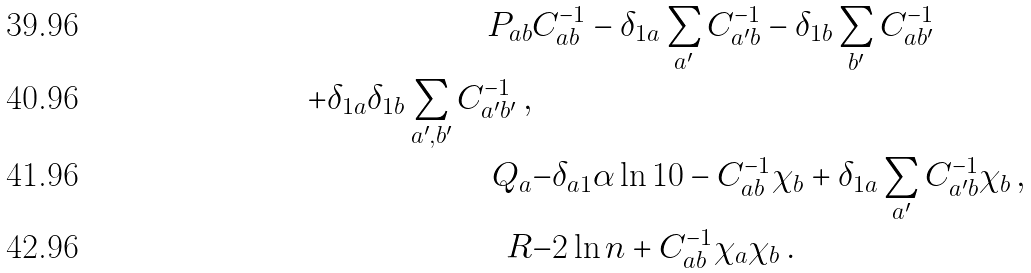Convert formula to latex. <formula><loc_0><loc_0><loc_500><loc_500>P _ { a b } & C ^ { - 1 } _ { a b } - \delta _ { 1 a } \sum _ { a ^ { \prime } } C ^ { - 1 } _ { a ^ { \prime } b } - \delta _ { 1 b } \sum _ { b ^ { \prime } } C ^ { - 1 } _ { a b ^ { \prime } } \\ + \delta _ { 1 a } \delta _ { 1 b } \sum _ { a ^ { \prime } , b ^ { \prime } } C ^ { - 1 } _ { a ^ { \prime } b ^ { \prime } } \, , \\ Q _ { a } & { - \delta _ { a 1 } } \alpha \ln 1 0 - C ^ { - 1 } _ { a b } \chi _ { b } + \delta _ { 1 a } \sum _ { a ^ { \prime } } C ^ { - 1 } _ { a ^ { \prime } b } \chi _ { b } \, , \\ R & { - 2 \ln n } + C ^ { - 1 } _ { a b } \chi _ { a } \chi _ { b } \, .</formula> 